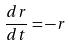Convert formula to latex. <formula><loc_0><loc_0><loc_500><loc_500>\frac { d r } { d t } = - r</formula> 